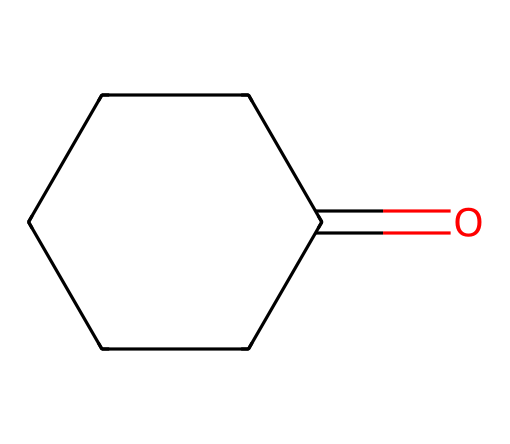What is the molecular formula of cyclohexanone? To find the molecular formula, count the number of carbon (C), hydrogen (H), and oxygen (O) atoms in the structure. There are six carbon atoms, ten hydrogen atoms, and one oxygen atom. Therefore, the molecular formula is C6H10O.
Answer: C6H10O How many carbon atoms are in cyclohexanone? The structure shown has six carbon atoms present in the cyclic arrangement. Thus, the answer is simply the count of these atoms.
Answer: six What type of functional group is present in cyclohexanone? Cyclohexanone belongs to the class of ketones, which is characterized by a carbonyl group (C=O) attached to two carbon atoms. This functional group is indicated by the presence of the carbonyl (C=O) in the structure.
Answer: ketone What is the total number of hydrogen atoms in cyclohexanone? By examining the structure, there are ten hydrogen atoms attached to the six carbon atoms, making the total count equal to ten.
Answer: ten Does cyclohexanone contain any double bonds? The only double bond present in cyclohexanone is the carbonyl group (C=O). Since there are no other double bonds indicated by the structure, only this one exists.
Answer: yes How many rings are present in cyclohexanone? Upon examining the structure, it is evident that there is one closed-loop structure (ring) formed by the six carbon atoms. Therefore, the answer reflects the number of rings visible.
Answer: one What impact does the carbonyl group have on the reactivity of cyclohexanone? The presence of the carbonyl group enhances the reactivity of cyclohexanone, making it susceptible to nucleophilic attack, typical of ketones. This reactivity stems from the partial positive charge on the carbon atom of the carbonyl group.
Answer: increases reactivity 